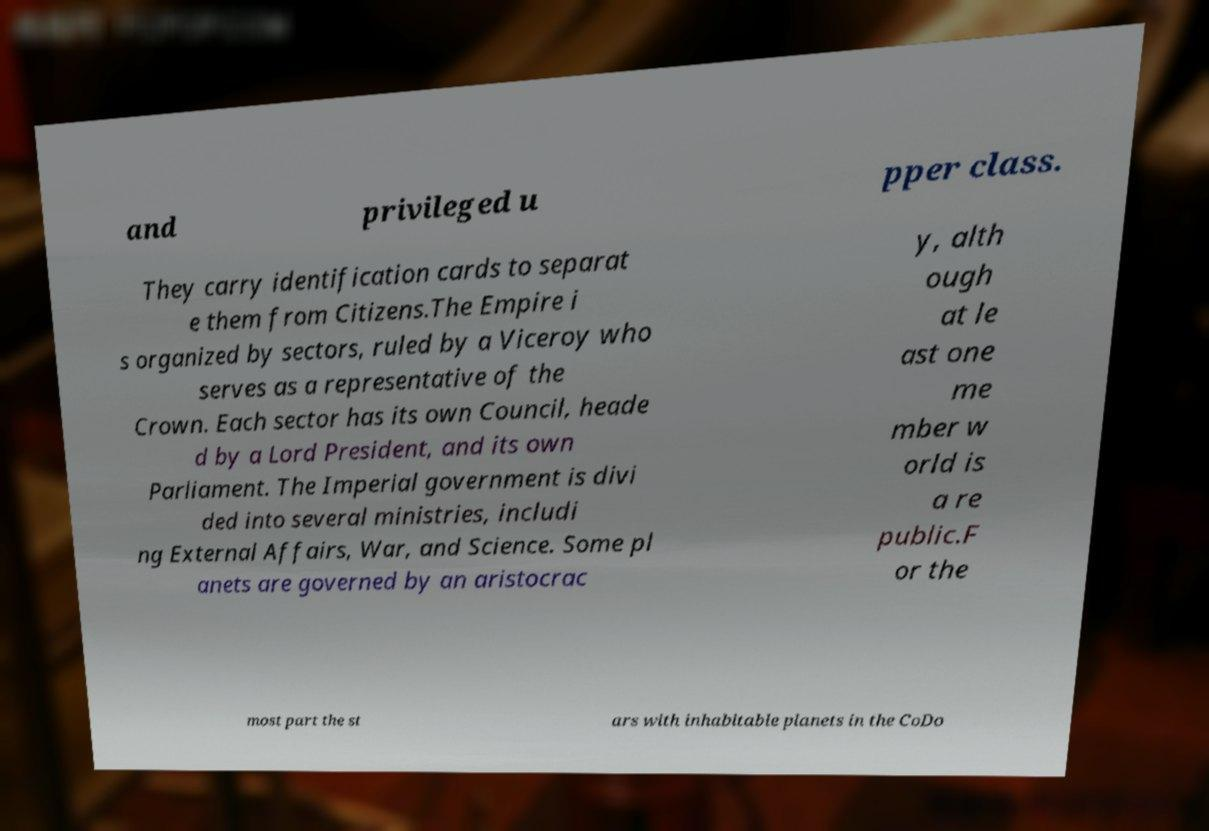Please identify and transcribe the text found in this image. and privileged u pper class. They carry identification cards to separat e them from Citizens.The Empire i s organized by sectors, ruled by a Viceroy who serves as a representative of the Crown. Each sector has its own Council, heade d by a Lord President, and its own Parliament. The Imperial government is divi ded into several ministries, includi ng External Affairs, War, and Science. Some pl anets are governed by an aristocrac y, alth ough at le ast one me mber w orld is a re public.F or the most part the st ars with inhabitable planets in the CoDo 